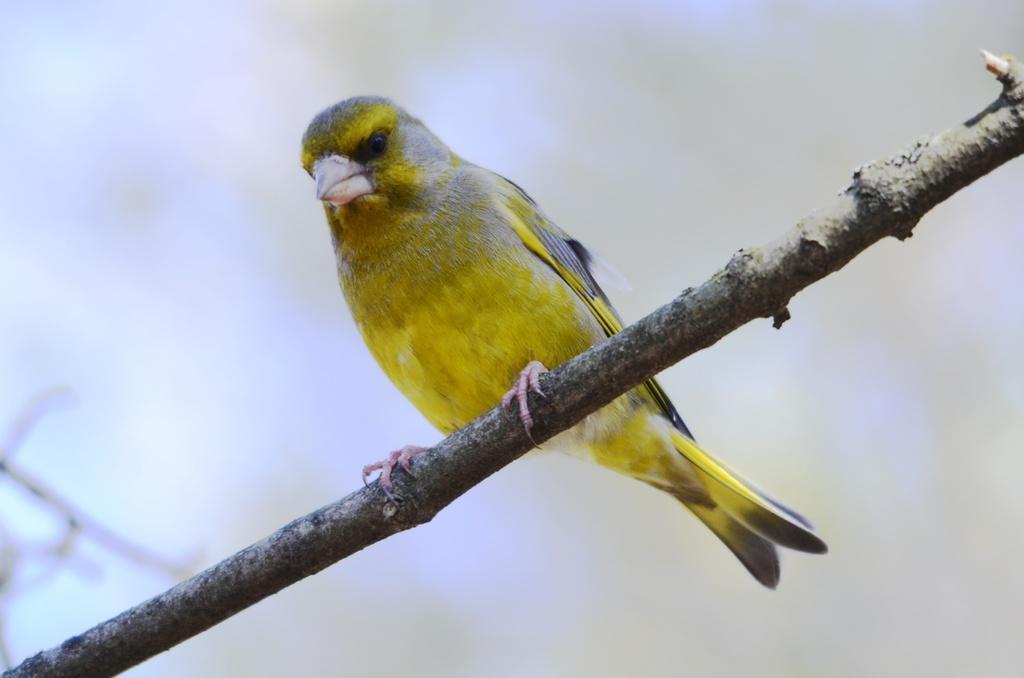In one or two sentences, can you explain what this image depicts? In this image I can see wooden stick and on it I can see a yellow colour bird. I can see this image is little bit blurry from background. 